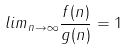Convert formula to latex. <formula><loc_0><loc_0><loc_500><loc_500>l i m _ { n \rightarrow \infty } \frac { f ( n ) } { g ( n ) } = 1</formula> 